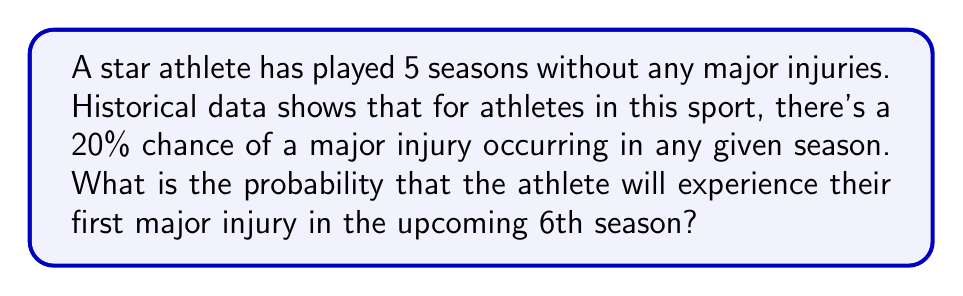Show me your answer to this math problem. Let's approach this step-by-step:

1) First, we need to calculate the probability of the athlete not getting injured in any given season:
   $P(\text{no injury}) = 1 - P(\text{injury}) = 1 - 0.20 = 0.80$ or 80%

2) For the athlete to experience their first injury in the 6th season, they must:
   a) Not get injured in the first 5 seasons, AND
   b) Get injured in the 6th season

3) The probability of not getting injured for 5 consecutive seasons is:
   $P(\text{no injury for 5 seasons}) = 0.80^5 = 0.32768$ or about 32.768%

4) Now, we need to multiply this by the probability of getting injured in the 6th season:
   $P(\text{first injury in 6th season}) = P(\text{no injury for 5 seasons}) \times P(\text{injury in 6th season})$

5) Plugging in the values:
   $P(\text{first injury in 6th season}) = 0.32768 \times 0.20 = 0.065536$

6) Converting to a percentage:
   $0.065536 \times 100\% = 6.5536\%$
Answer: $6.5536\%$ 